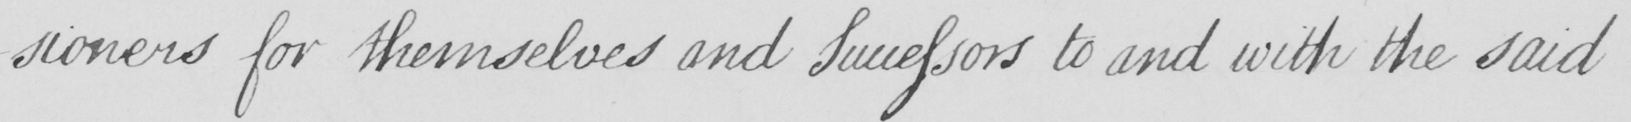Can you tell me what this handwritten text says? -sioners for themselves and Successors to and with the said 